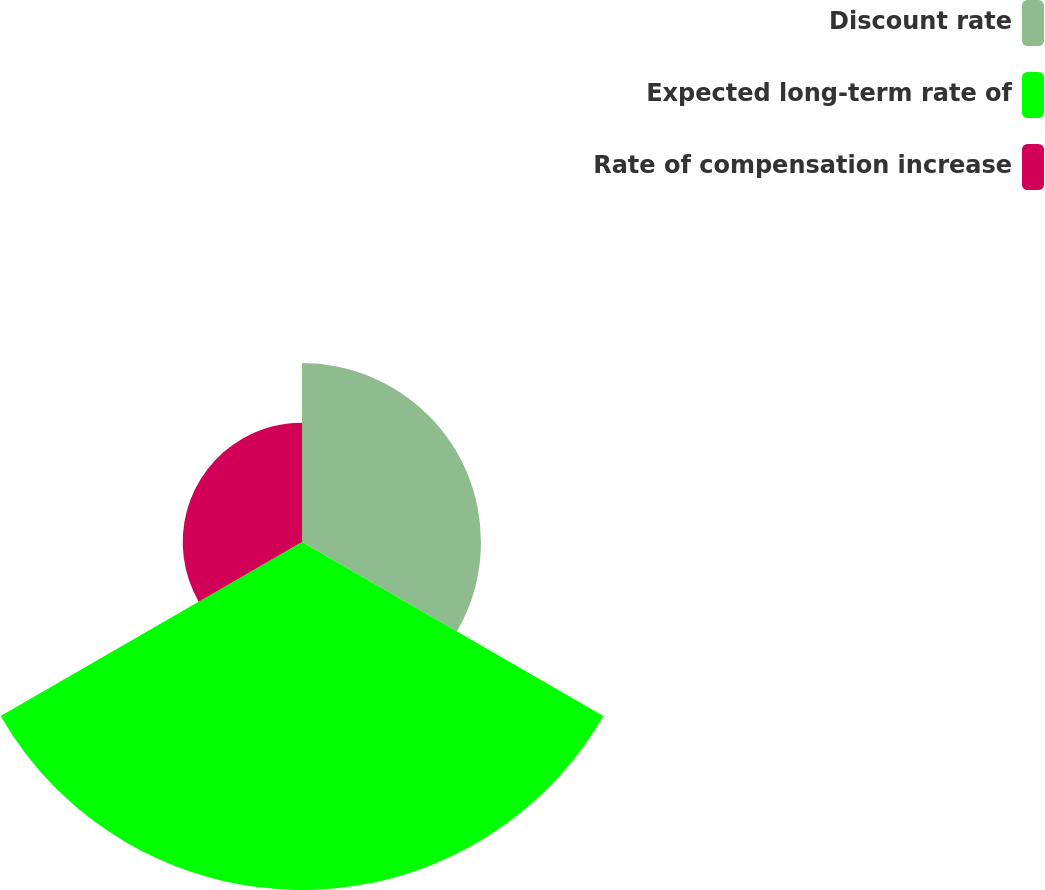<chart> <loc_0><loc_0><loc_500><loc_500><pie_chart><fcel>Discount rate<fcel>Expected long-term rate of<fcel>Rate of compensation increase<nl><fcel>27.69%<fcel>53.85%<fcel>18.46%<nl></chart> 